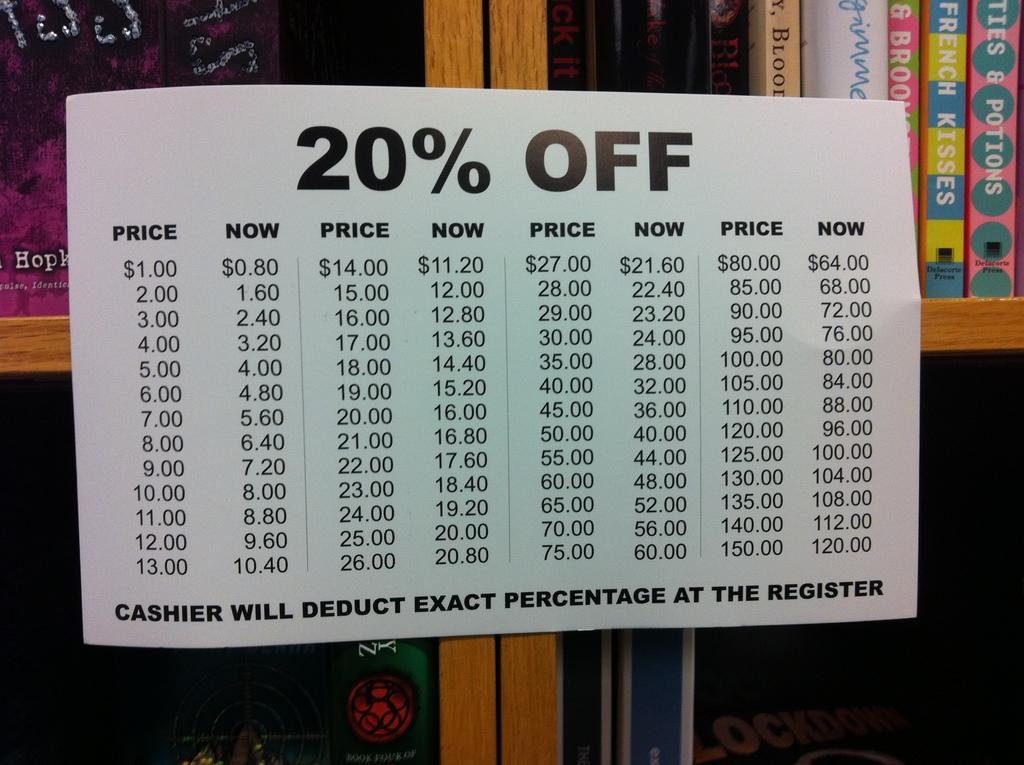What will the cashier deduct?
Make the answer very short. 20%. 